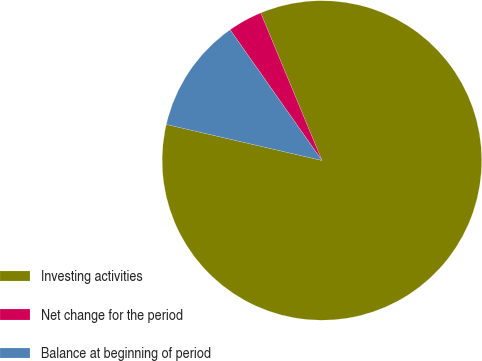Convert chart. <chart><loc_0><loc_0><loc_500><loc_500><pie_chart><fcel>Investing activities<fcel>Net change for the period<fcel>Balance at beginning of period<nl><fcel>84.88%<fcel>3.49%<fcel>11.63%<nl></chart> 